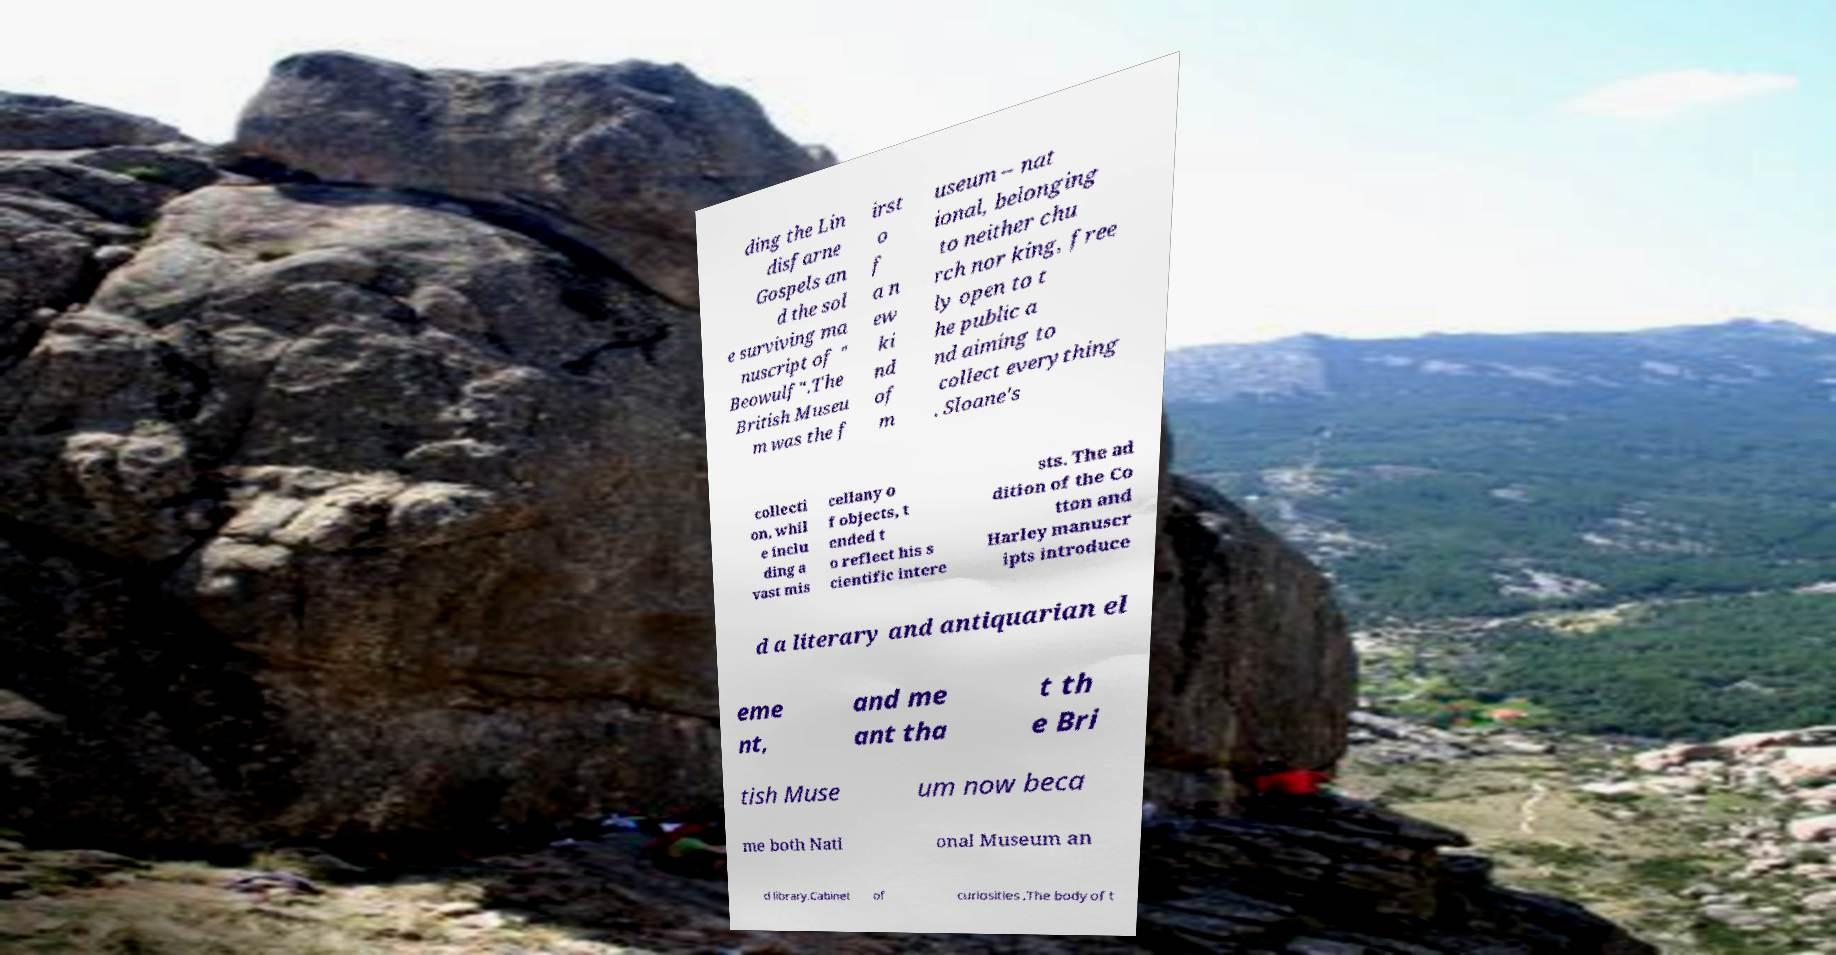What messages or text are displayed in this image? I need them in a readable, typed format. ding the Lin disfarne Gospels an d the sol e surviving ma nuscript of " Beowulf".The British Museu m was the f irst o f a n ew ki nd of m useum – nat ional, belonging to neither chu rch nor king, free ly open to t he public a nd aiming to collect everything . Sloane's collecti on, whil e inclu ding a vast mis cellany o f objects, t ended t o reflect his s cientific intere sts. The ad dition of the Co tton and Harley manuscr ipts introduce d a literary and antiquarian el eme nt, and me ant tha t th e Bri tish Muse um now beca me both Nati onal Museum an d library.Cabinet of curiosities .The body of t 